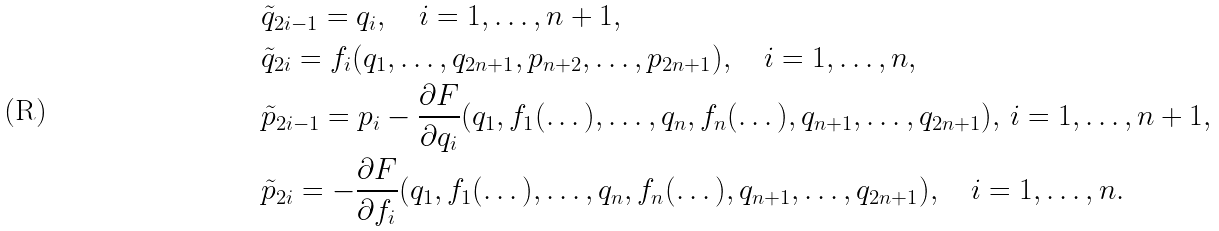<formula> <loc_0><loc_0><loc_500><loc_500>& \tilde { q } _ { 2 i - 1 } = q _ { i } , \quad i = 1 , \dots , n + 1 , \\ & \tilde { q } _ { 2 i } = f _ { i } ( q _ { 1 } , \dots , q _ { 2 n + 1 } , p _ { n + 2 } , \dots , p _ { 2 n + 1 } ) , \quad i = 1 , \dots , n , \\ & \tilde { p } _ { 2 i - 1 } = p _ { i } - \frac { \partial F } { \partial q _ { i } } ( q _ { 1 } , f _ { 1 } ( \dots ) , \dots , q _ { n } , f _ { n } ( \dots ) , q _ { n + 1 } , \dots , q _ { 2 n + 1 } ) , \, i = 1 , \dots , n + 1 , \\ & \tilde { p } _ { 2 i } = - \frac { \partial F } { \partial f _ { i } } ( q _ { 1 } , f _ { 1 } ( \dots ) , \dots , q _ { n } , f _ { n } ( \dots ) , q _ { n + 1 } , \dots , q _ { 2 n + 1 } ) , \quad i = 1 , \dots , n .</formula> 